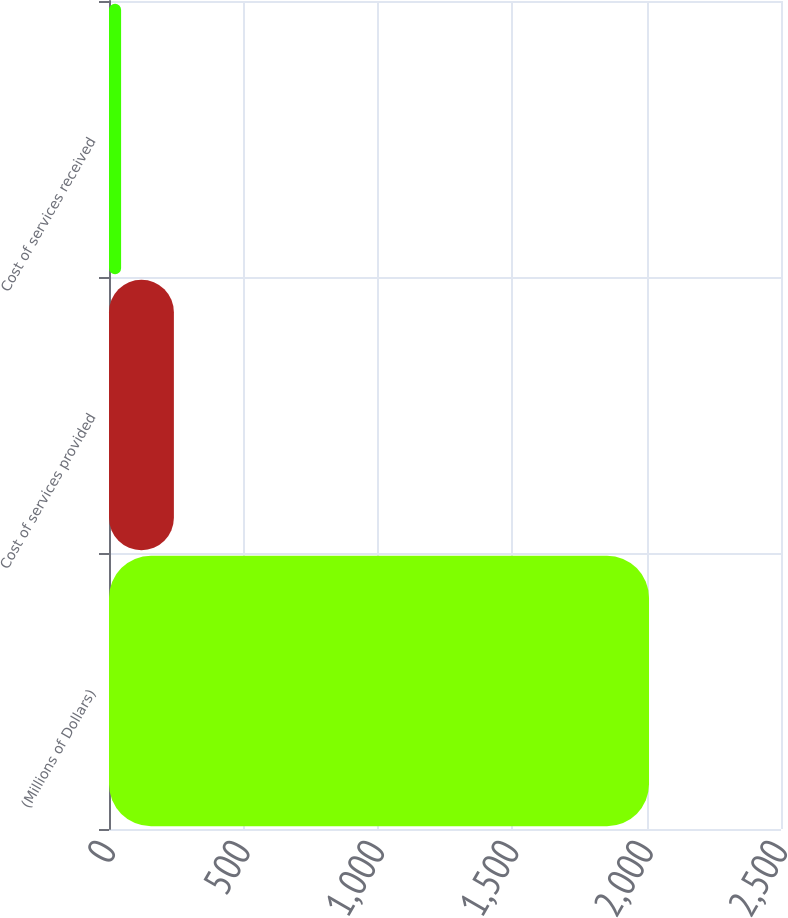<chart> <loc_0><loc_0><loc_500><loc_500><bar_chart><fcel>(Millions of Dollars)<fcel>Cost of services provided<fcel>Cost of services received<nl><fcel>2009<fcel>241.4<fcel>45<nl></chart> 